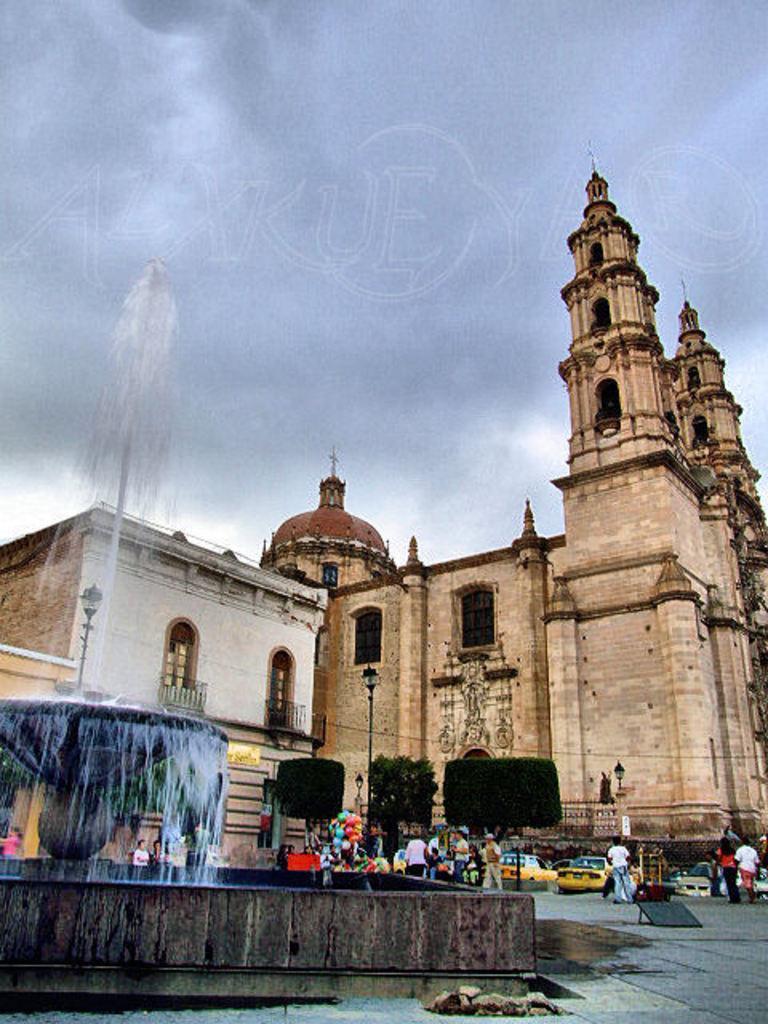Could you give a brief overview of what you see in this image? On the left side there is a waterfall, in the middle there are few people and vehicles on the road, this is a big fort in the middle of an image. At the top it is a cloudy sky. 